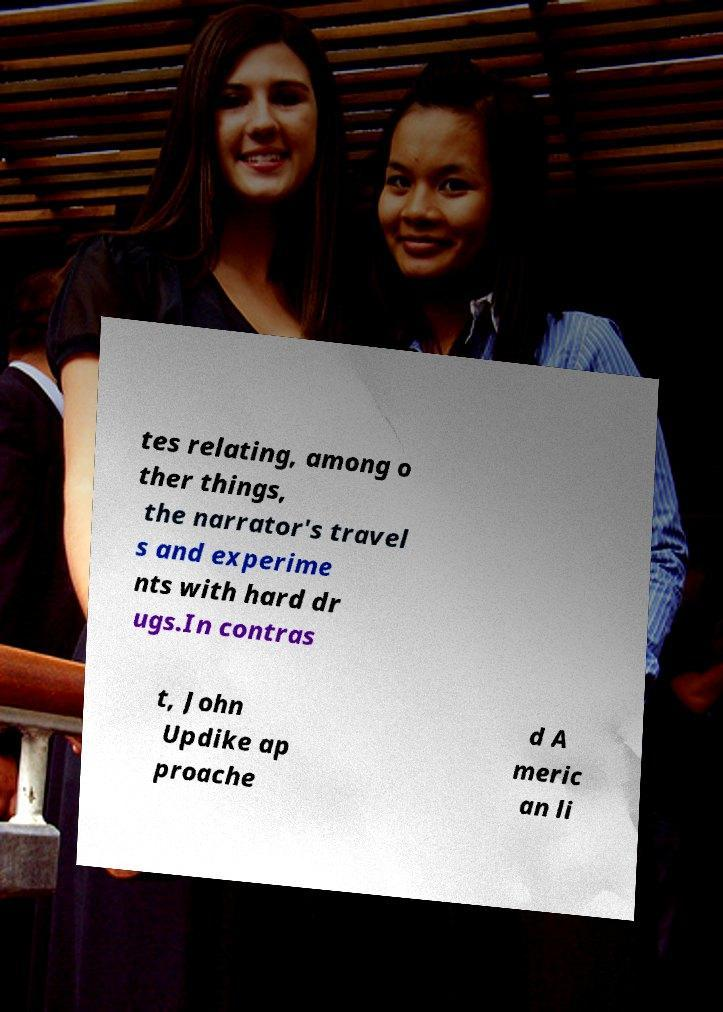I need the written content from this picture converted into text. Can you do that? tes relating, among o ther things, the narrator's travel s and experime nts with hard dr ugs.In contras t, John Updike ap proache d A meric an li 